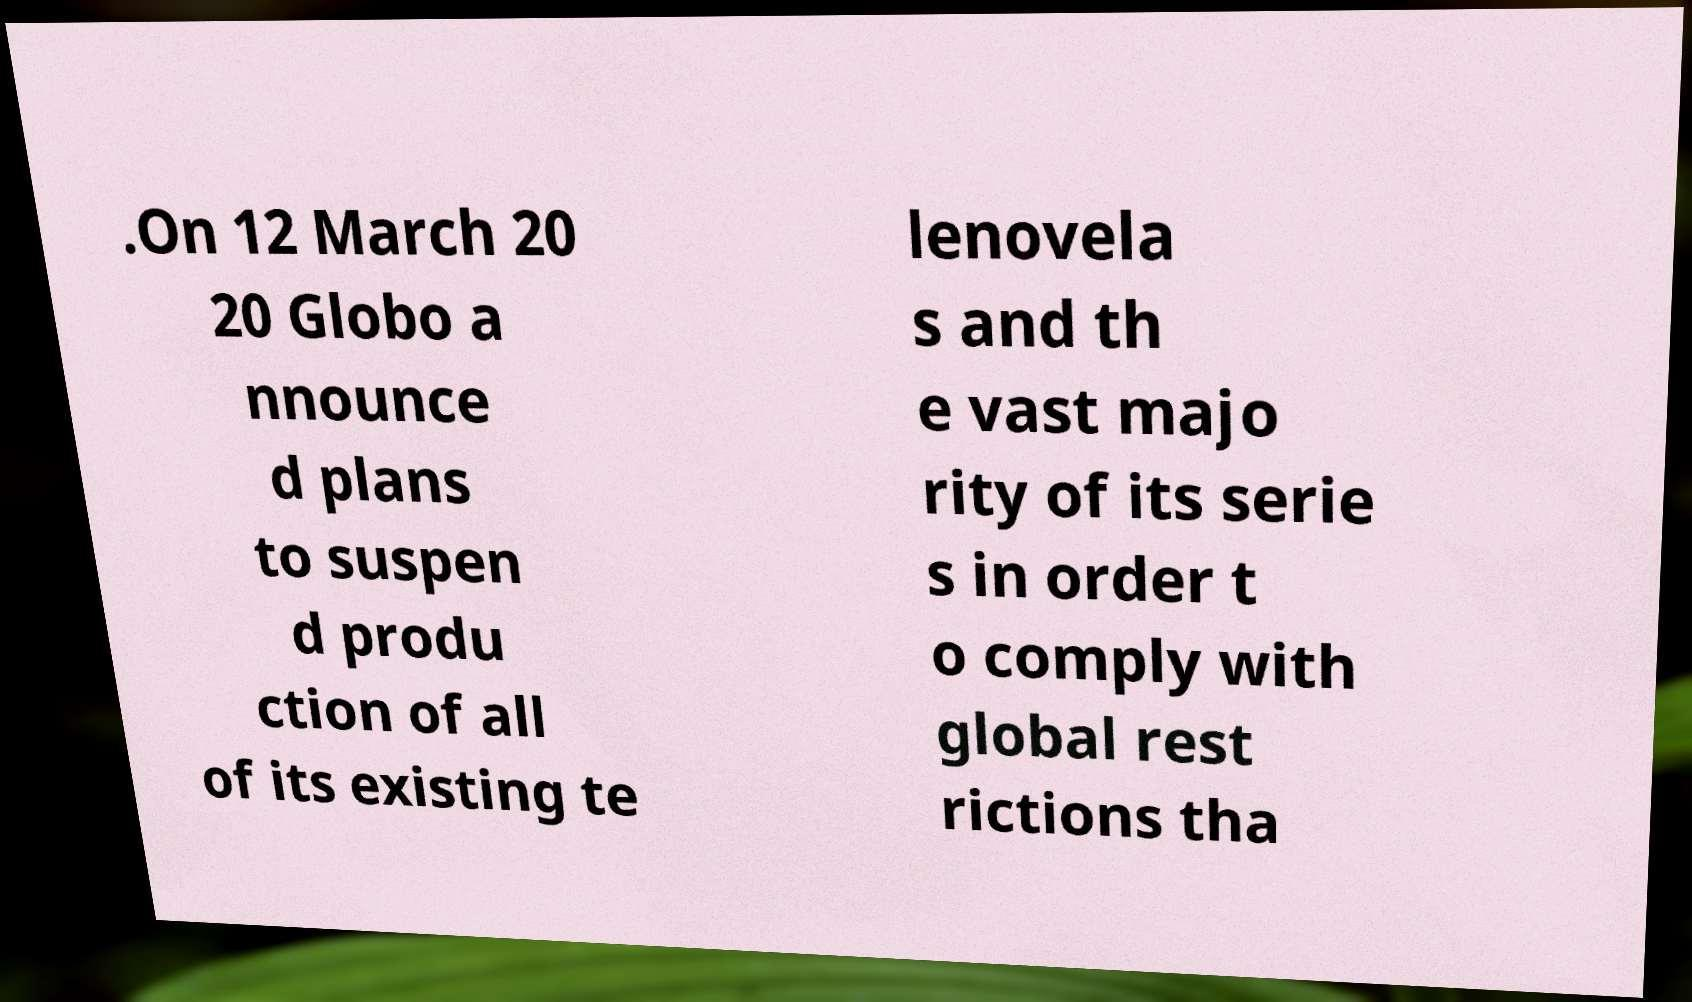I need the written content from this picture converted into text. Can you do that? .On 12 March 20 20 Globo a nnounce d plans to suspen d produ ction of all of its existing te lenovela s and th e vast majo rity of its serie s in order t o comply with global rest rictions tha 